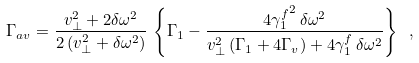Convert formula to latex. <formula><loc_0><loc_0><loc_500><loc_500>\Gamma _ { a v } = \frac { v _ { \perp } ^ { 2 } + 2 \delta \omega ^ { 2 } } { 2 \left ( v _ { \perp } ^ { 2 } + \delta \omega ^ { 2 } \right ) } \, \left \{ \Gamma _ { 1 } - \frac { 4 { \gamma _ { 1 } ^ { f } } ^ { 2 } \, \delta \omega ^ { 2 } } { v _ { \perp } ^ { 2 } \left ( \Gamma _ { 1 } + 4 \Gamma _ { v } \right ) + 4 \gamma _ { 1 } ^ { f } \, \delta \omega ^ { 2 } } \right \} \ ,</formula> 